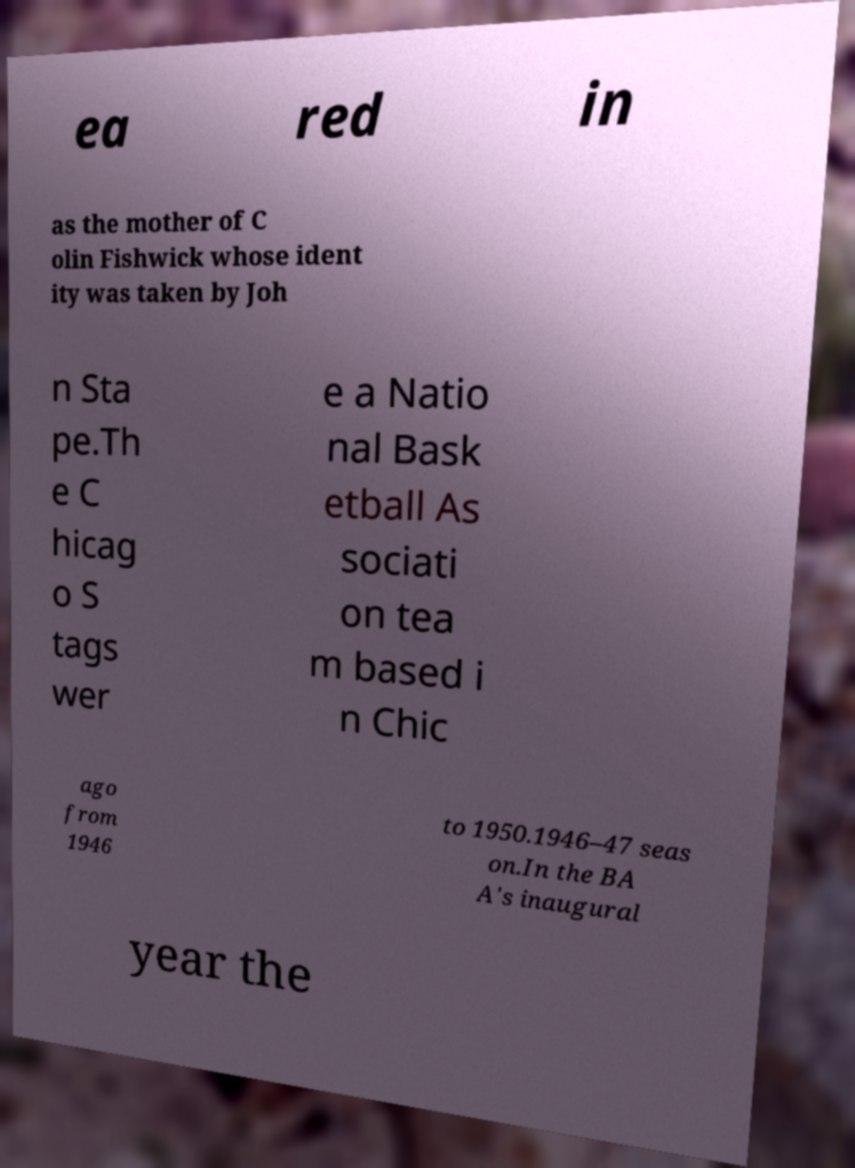I need the written content from this picture converted into text. Can you do that? ea red in as the mother of C olin Fishwick whose ident ity was taken by Joh n Sta pe.Th e C hicag o S tags wer e a Natio nal Bask etball As sociati on tea m based i n Chic ago from 1946 to 1950.1946–47 seas on.In the BA A's inaugural year the 